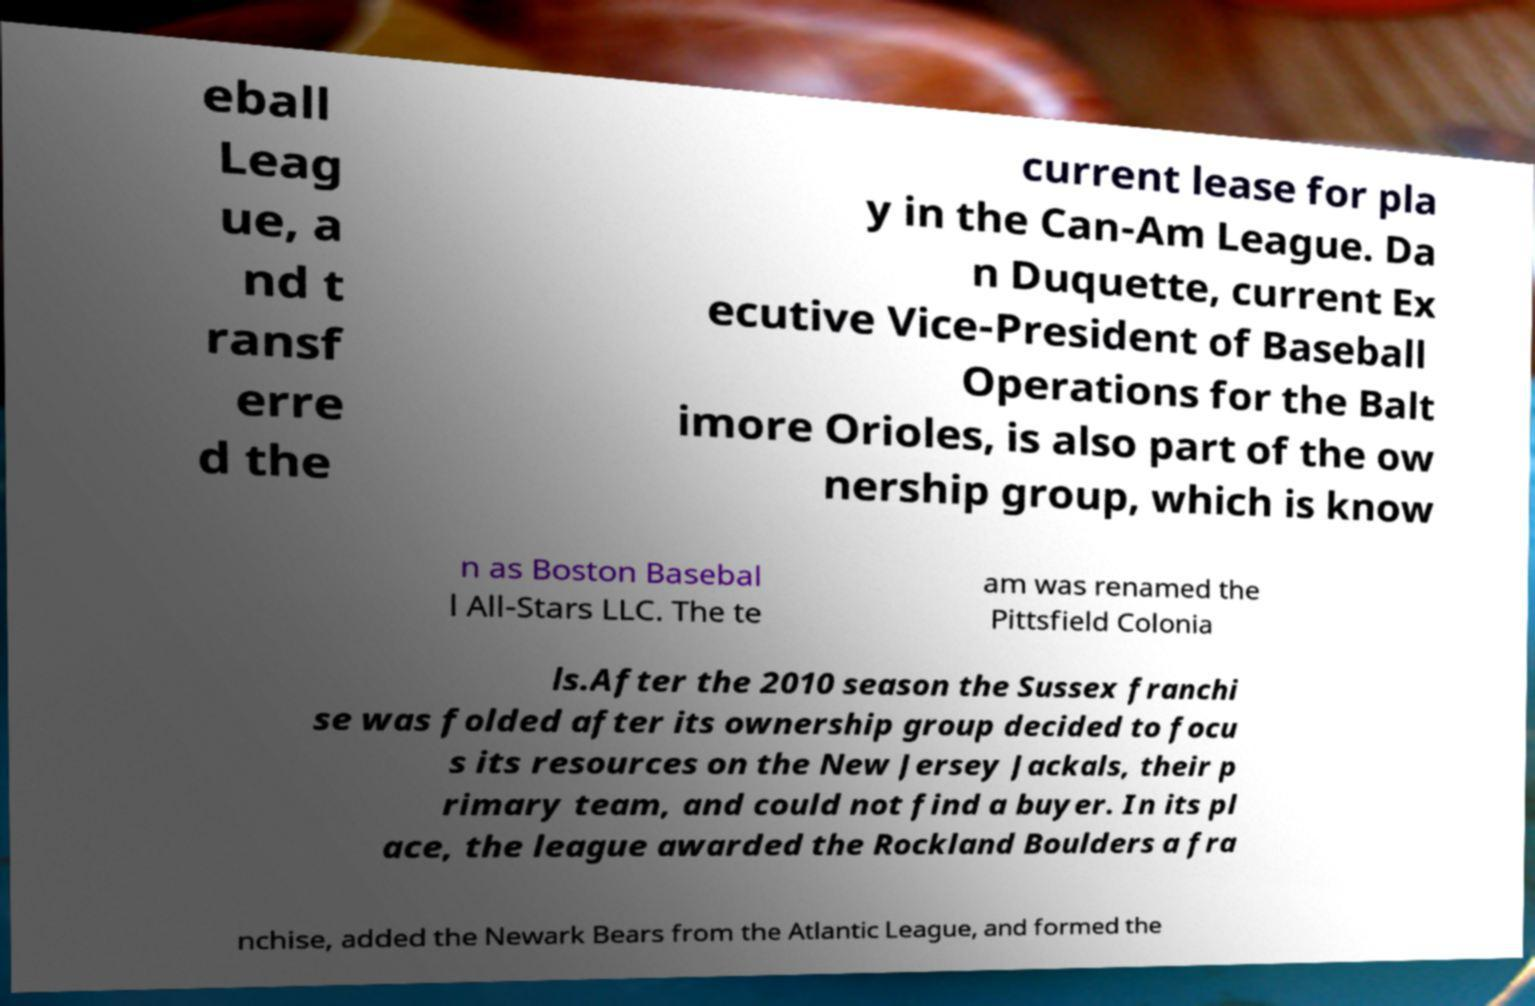Could you extract and type out the text from this image? eball Leag ue, a nd t ransf erre d the current lease for pla y in the Can-Am League. Da n Duquette, current Ex ecutive Vice-President of Baseball Operations for the Balt imore Orioles, is also part of the ow nership group, which is know n as Boston Basebal l All-Stars LLC. The te am was renamed the Pittsfield Colonia ls.After the 2010 season the Sussex franchi se was folded after its ownership group decided to focu s its resources on the New Jersey Jackals, their p rimary team, and could not find a buyer. In its pl ace, the league awarded the Rockland Boulders a fra nchise, added the Newark Bears from the Atlantic League, and formed the 